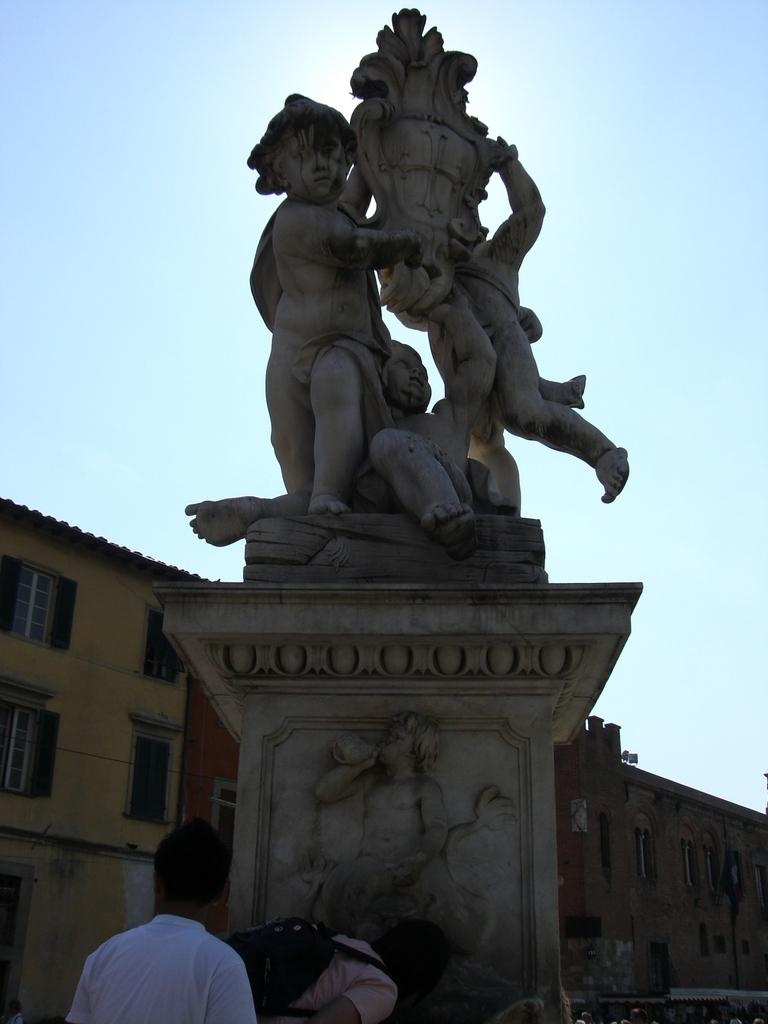What is the main subject in the image? There is a statue in the image. Who or what is located near the statue? There are two persons below the statue. What can be seen in the distance behind the statue? There are buildings in the background of the image. What type of scarf is the statue wearing in the image? The statue is not wearing a scarf in the image, as statues are typically made of inanimate materials like stone or metal. 